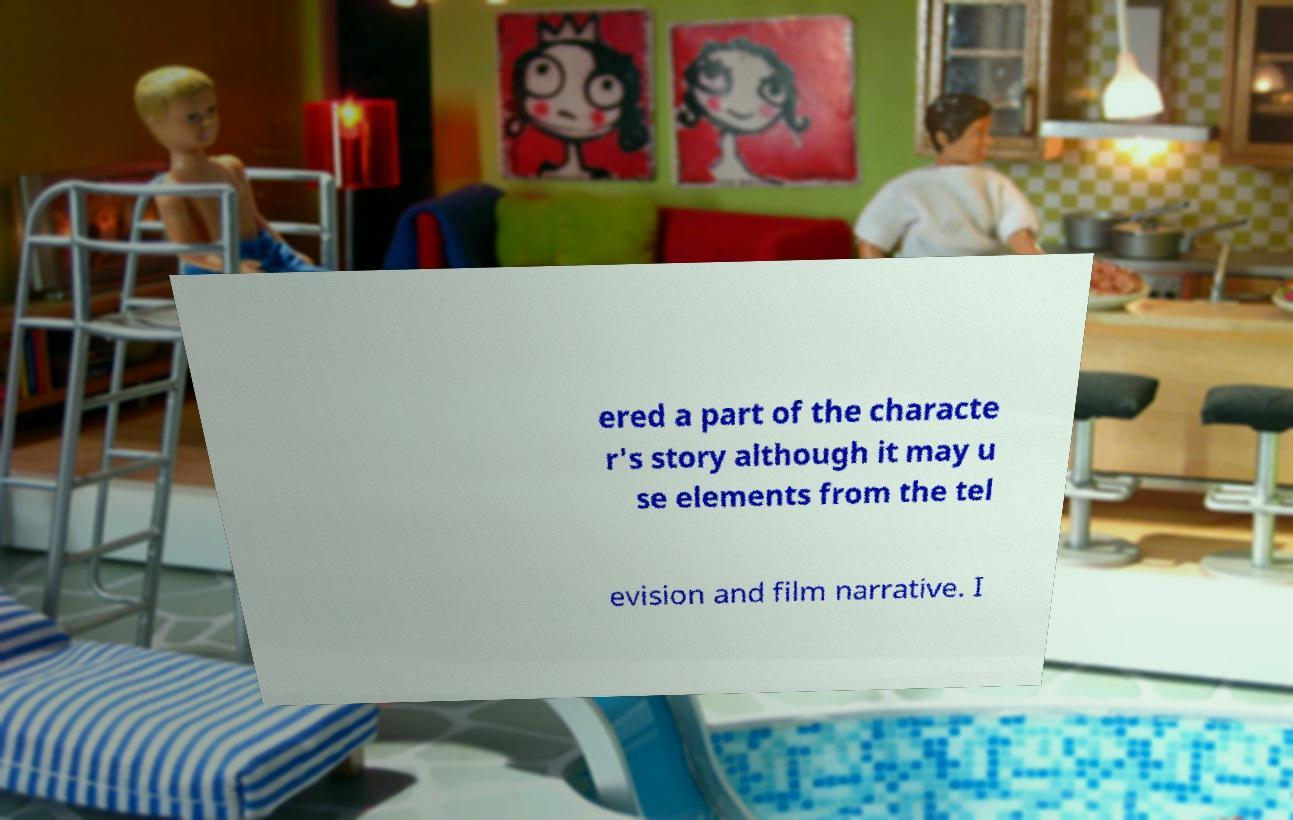Please read and relay the text visible in this image. What does it say? ered a part of the characte r's story although it may u se elements from the tel evision and film narrative. I 